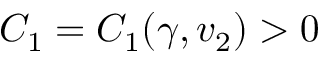<formula> <loc_0><loc_0><loc_500><loc_500>C _ { 1 } = C _ { 1 } ( \gamma , v _ { 2 } ) > 0</formula> 